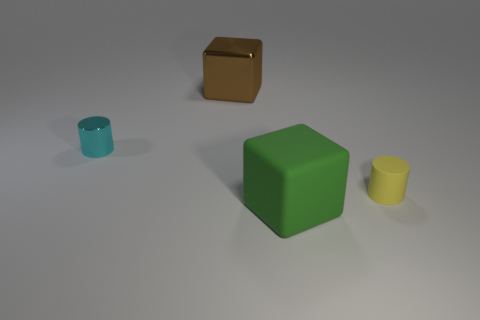Add 3 large green matte objects. How many objects exist? 7 Add 4 small purple matte objects. How many small purple matte objects exist? 4 Subtract 0 yellow cubes. How many objects are left? 4 Subtract all gray shiny balls. Subtract all big brown things. How many objects are left? 3 Add 4 brown blocks. How many brown blocks are left? 5 